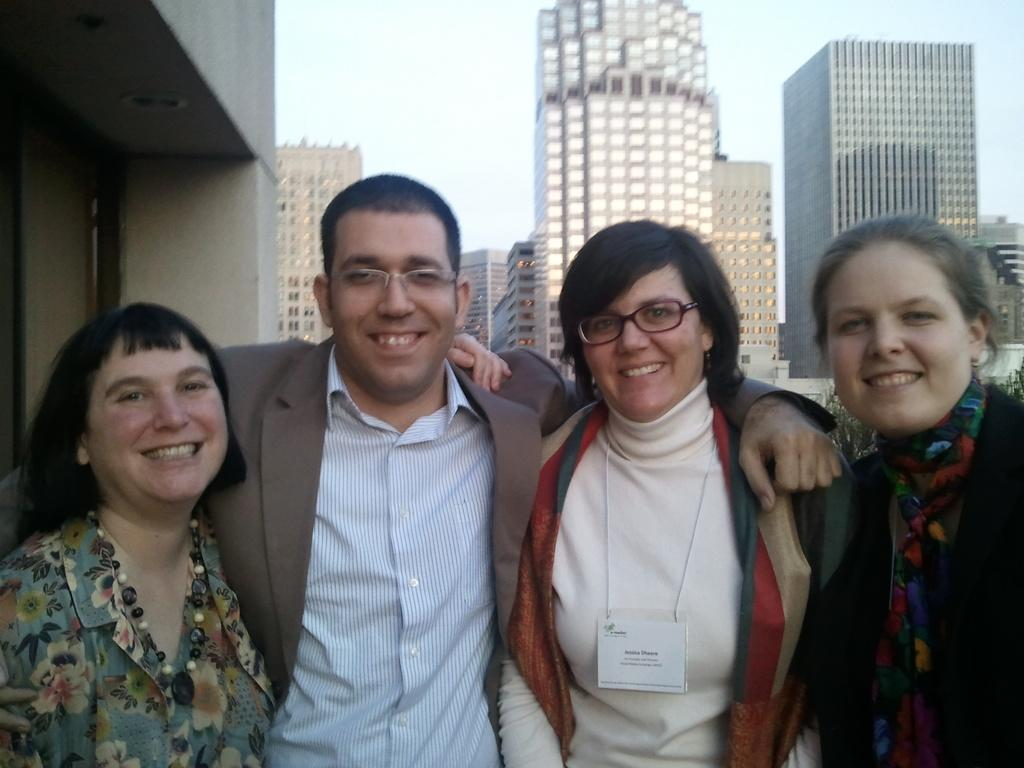How many people are present in the image? There are four people standing in the image. What is the facial expression of the people in the image? The people are smiling. What can be seen in the background of the image? There are buildings visible in the background of the image. What type of lunch is being served in the image? There is no lunch present in the image; it only features four people standing and smiling with buildings in the background. 